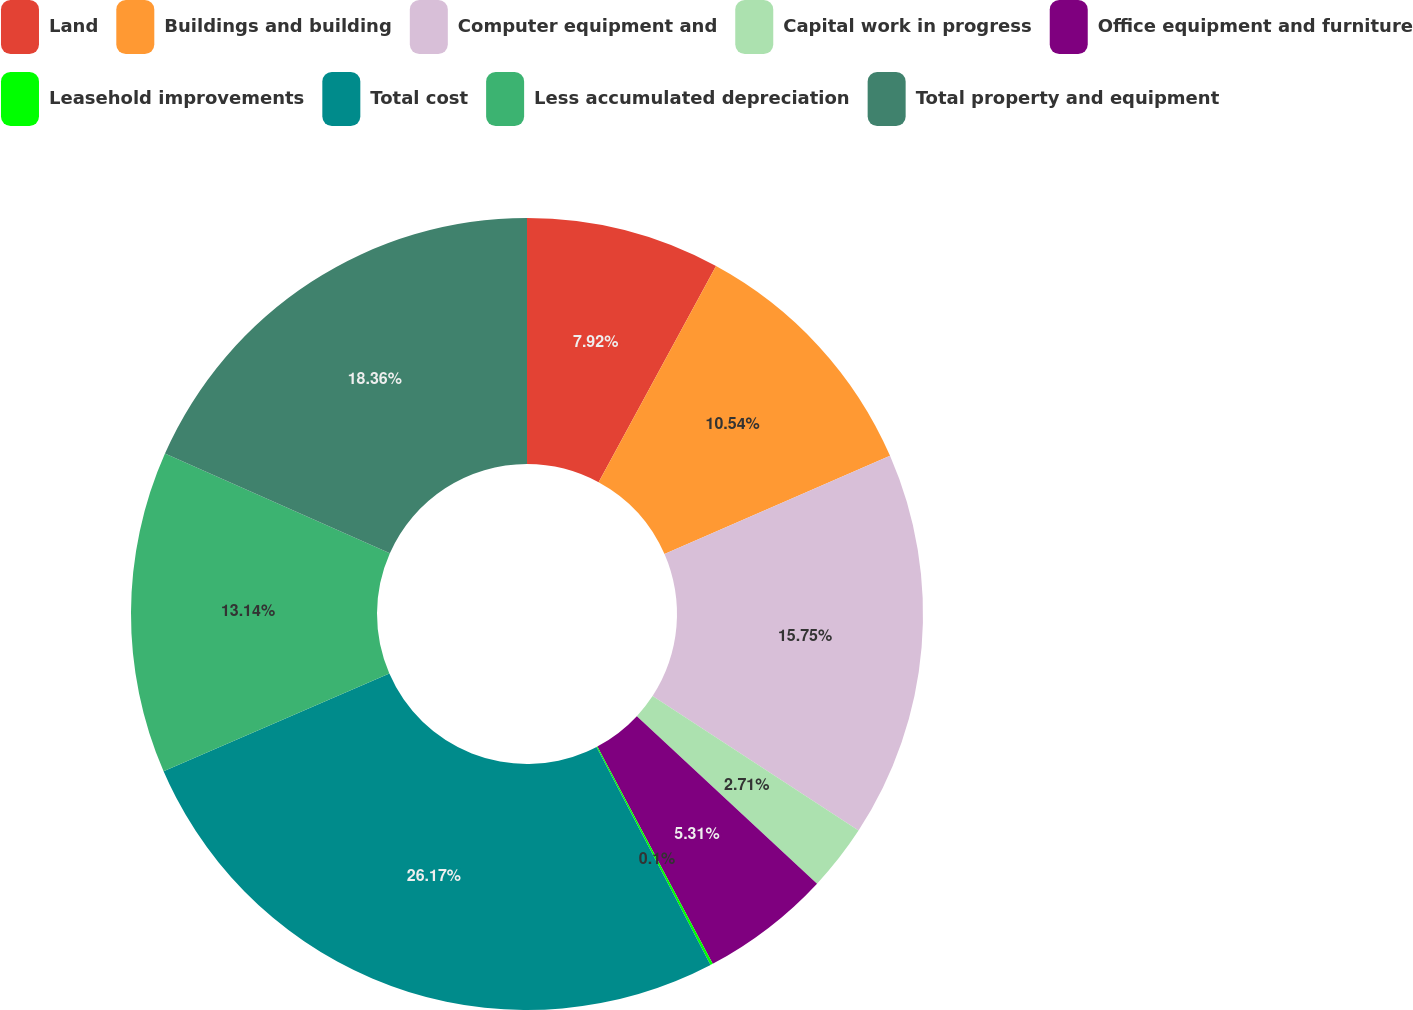<chart> <loc_0><loc_0><loc_500><loc_500><pie_chart><fcel>Land<fcel>Buildings and building<fcel>Computer equipment and<fcel>Capital work in progress<fcel>Office equipment and furniture<fcel>Leasehold improvements<fcel>Total cost<fcel>Less accumulated depreciation<fcel>Total property and equipment<nl><fcel>7.92%<fcel>10.54%<fcel>15.75%<fcel>2.71%<fcel>5.31%<fcel>0.1%<fcel>26.17%<fcel>13.14%<fcel>18.36%<nl></chart> 